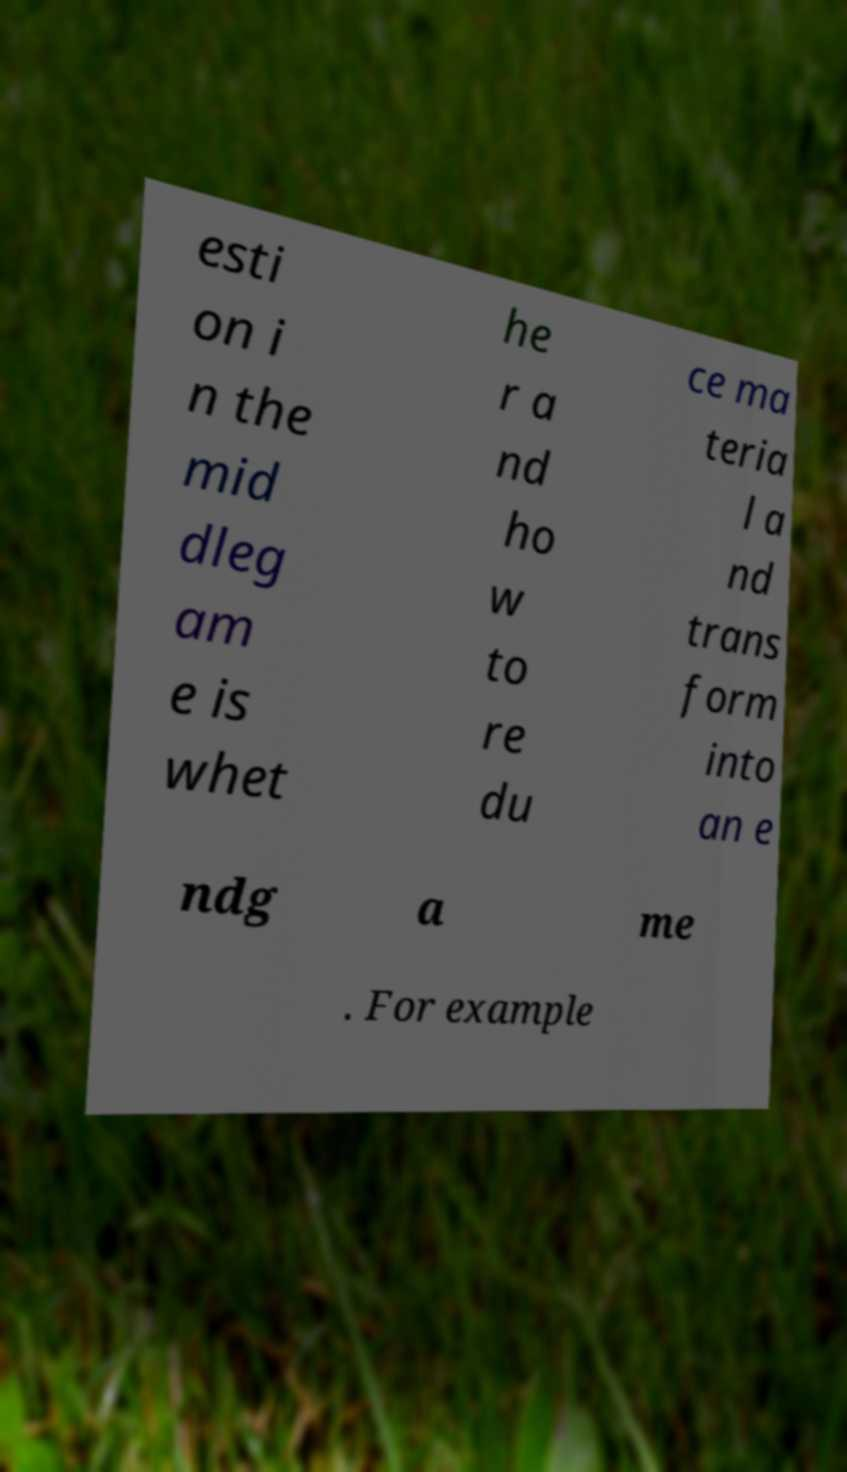Please identify and transcribe the text found in this image. esti on i n the mid dleg am e is whet he r a nd ho w to re du ce ma teria l a nd trans form into an e ndg a me . For example 